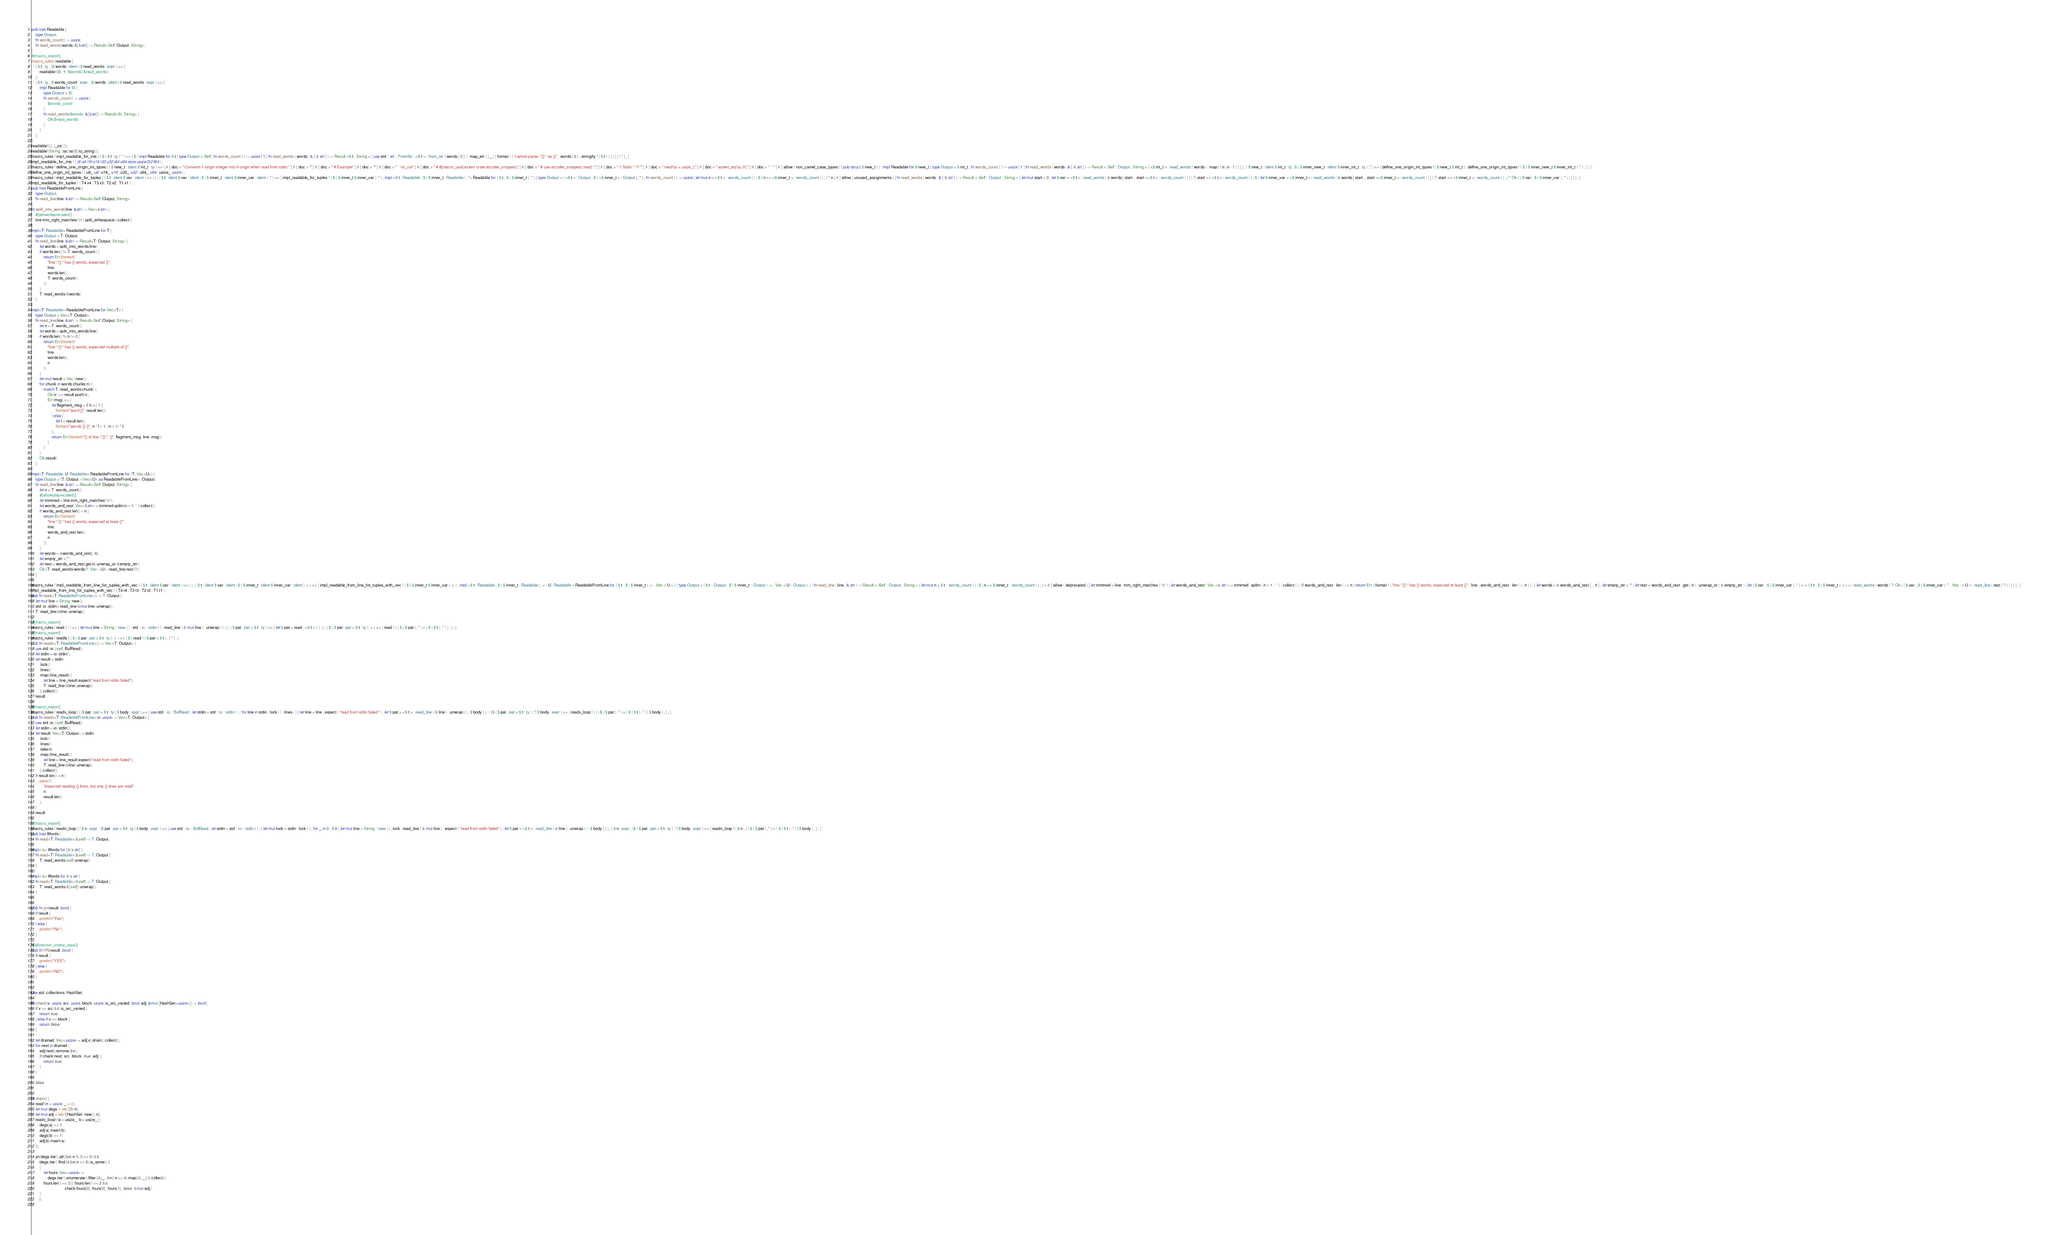<code> <loc_0><loc_0><loc_500><loc_500><_Rust_>pub trait Readable {
    type Output;
    fn words_count() -> usize;
    fn read_words(words: &[&str]) -> Result<Self::Output, String>;
}
#[macro_export]
macro_rules! readable {
    ( $ t : ty , |$ words : ident | $ read_words : expr ) => {
        readable!($t, 1, |$words| $read_words);
    };
    ( $ t : ty , $ words_count : expr , |$ words : ident | $ read_words : expr ) => {
        impl Readable for $t {
            type Output = $t;
            fn words_count() -> usize {
                $words_count
            }
            fn read_words($words: &[&str]) -> Result<$t, String> {
                Ok($read_words)
            }
        }
    };
}
readable!((), |_ss| ());
readable!(String, |ss| ss[0].to_string());
macro_rules ! impl_readable_for_ints { ( $ ( $ t : ty ) * ) => { $ ( impl Readable for $ t { type Output = Self ; fn words_count ( ) -> usize { 1 } fn read_words ( words : & [ & str ] ) -> Result <$ t , String > { use std :: str :: FromStr ; <$ t >:: from_str ( words [ 0 ] ) . map_err ( | _ | { format ! ( "cannot parse \"{}\" as {}" , words [ 0 ] , stringify ! ( $ t ) ) } ) } } ) * } ; }
impl_readable_for_ints ! ( i8 u8 i16 u16 i32 u32 i64 u64 isize usize f32 f64 ) ;
macro_rules ! define_one_origin_int_types { ( $ new_t : ident $ int_t : ty ) => { # [ doc = " Converts 1-origin integer into 0-origin when read from stdin." ] # [ doc = "" ] # [ doc = " # Example" ] # [ doc = "" ] # [ doc = " ```no_run" ] # [ doc = " # #[macro_use] extern crate atcoder_snippets;" ] # [ doc = " # use atcoder_snippets::read::*;" ] # [ doc = " // Stdin: \"1\"" ] # [ doc = " read!(a = usize_);" ] # [ doc = " assert_eq!(a, 0);" ] # [ doc = " ```" ] # [ allow ( non_camel_case_types ) ] pub struct $ new_t ( ) ; impl Readable for $ new_t { type Output = $ int_t ; fn words_count ( ) -> usize { 1 } fn read_words ( words : & [ & str ] ) -> Result < Self :: Output , String > { <$ int_t >:: read_words ( words ) . map ( | n | n - 1 ) } } } ; ( $ new_t : ident $ int_t : ty ; $ ( $ inner_new_t : ident $ inner_int_t : ty ) ;* ) => { define_one_origin_int_types ! ( $ new_t $ int_t ) ; define_one_origin_int_types ! ( $ ( $ inner_new_t $ inner_int_t ) ;* ) ; } ; }
define_one_origin_int_types ! ( u8_ u8 ; u16_ u16 ; u32_ u32 ; u64_ u64 ; usize_ usize ) ;
macro_rules ! impl_readable_for_tuples { ( $ t : ident $ var : ident ) => ( ) ; ( $ t : ident $ var : ident ; $ ( $ inner_t : ident $ inner_var : ident ) ;* ) => { impl_readable_for_tuples ! ( $ ( $ inner_t $ inner_var ) ;* ) ; impl <$ t : Readable , $ ( $ inner_t : Readable ) ,*> Readable for ( $ t , $ ( $ inner_t ) ,* ) { type Output = ( <$ t >:: Output , $ ( <$ inner_t >:: Output ) ,* ) ; fn words_count ( ) -> usize { let mut n = <$ t >:: words_count ( ) ; $ ( n += <$ inner_t >:: words_count ( ) ; ) * n } # [ allow ( unused_assignments ) ] fn read_words ( words : & [ & str ] ) -> Result < Self :: Output , String > { let mut start = 0 ; let $ var = <$ t >:: read_words ( & words [ start .. start +<$ t >:: words_count ( ) ] ) ?; start += <$ t >:: words_count ( ) ; $ ( let $ inner_var = <$ inner_t >:: read_words ( & words [ start .. start +<$ inner_t >:: words_count ( ) ] ) ?; start += <$ inner_t >:: words_count ( ) ; ) * Ok ( ( $ var , $ ( $ inner_var ) ,* ) ) } } } ; }
impl_readable_for_tuples ! ( T4 x4 ; T3 x3 ; T2 x2 ; T1 x1 ) ;
pub trait ReadableFromLine {
    type Output;
    fn read_line(line: &str) -> Result<Self::Output, String>;
}
fn split_into_words(line: &str) -> Vec<&str> {
    #[allow(deprecated)]
    line.trim_right_matches('\n').split_whitespace().collect()
}
impl<T: Readable> ReadableFromLine for T {
    type Output = T::Output;
    fn read_line(line: &str) -> Result<T::Output, String> {
        let words = split_into_words(line);
        if words.len() != T::words_count() {
            return Err(format!(
                "line \"{}\" has {} words, expected {}",
                line,
                words.len(),
                T::words_count()
            ));
        }
        T::read_words(&words)
    }
}
impl<T: Readable> ReadableFromLine for Vec<T> {
    type Output = Vec<T::Output>;
    fn read_line(line: &str) -> Result<Self::Output, String> {
        let n = T::words_count();
        let words = split_into_words(line);
        if words.len() % n != 0 {
            return Err(format!(
                "line \"{}\" has {} words, expected multiple of {}",
                line,
                words.len(),
                n
            ));
        }
        let mut result = Vec::new();
        for chunk in words.chunks(n) {
            match T::read_words(chunk) {
                Ok(v) => result.push(v),
                Err(msg) => {
                    let flagment_msg = if n == 1 {
                        format!("word {}", result.len())
                    } else {
                        let l = result.len();
                        format!("words {}-{}", n * l + 1, (n + 1) * l)
                    };
                    return Err(format!("{} of line \"{}\": {}", flagment_msg, line, msg));
                }
            }
        }
        Ok(result)
    }
}
impl<T: Readable, U: Readable> ReadableFromLine for (T, Vec<U>) {
    type Output = (T::Output, <Vec<U> as ReadableFromLine>::Output);
    fn read_line(line: &str) -> Result<Self::Output, String> {
        let n = T::words_count();
        #[allow(deprecated)]
        let trimmed = line.trim_right_matches('\n');
        let words_and_rest: Vec<&str> = trimmed.splitn(n + 1, ' ').collect();
        if words_and_rest.len() < n {
            return Err(format!(
                "line \"{}\" has {} words, expected at least {}",
                line,
                words_and_rest.len(),
                n
            ));
        }
        let words = &words_and_rest[..n];
        let empty_str = "";
        let rest = words_and_rest.get(n).unwrap_or(&empty_str);
        Ok((T::read_words(words)?, Vec::<U>::read_line(rest)?))
    }
}
macro_rules ! impl_readable_from_line_for_tuples_with_vec { ( $ t : ident $ var : ident ) => ( ) ; ( $ t : ident $ var : ident ; $ ( $ inner_t : ident $ inner_var : ident ) ;+ ) => { impl_readable_from_line_for_tuples_with_vec ! ( $ ( $ inner_t $ inner_var ) ;+ ) ; impl <$ t : Readable , $ ( $ inner_t : Readable ) ,+ , U : Readable > ReadableFromLine for ( $ t , $ ( $ inner_t ) ,+ , Vec < U > ) { type Output = ( $ t :: Output , $ ( $ inner_t :: Output ) ,+ , Vec < U :: Output > ) ; fn read_line ( line : & str ) -> Result < Self :: Output , String > { let mut n = $ t :: words_count ( ) ; $ ( n += $ inner_t :: words_count ( ) ; ) + # [ allow ( deprecated ) ] let trimmed = line . trim_right_matches ( '\n' ) ; let words_and_rest : Vec <& str > = trimmed . splitn ( n + 1 , ' ' ) . collect ( ) ; if words_and_rest . len ( ) < n { return Err ( format ! ( "line \"{}\" has {} words, expected at least {}" , line , words_and_rest . len ( ) , n ) ) ; } let words = & words_and_rest [ .. n ] ; let empty_str = "" ; let rest = words_and_rest . get ( n ) . unwrap_or ( & empty_str ) ; let ( $ var , $ ( $ inner_var ) ,* ) = < ( $ t , $ ( $ inner_t ) ,+ ) >:: read_words ( words ) ?; Ok ( ( $ var , $ ( $ inner_var ) ,* , Vec ::< U >:: read_line ( rest ) ? ) ) } } } ; }
impl_readable_from_line_for_tuples_with_vec ! ( T4 t4 ; T3 t3 ; T2 t2 ; T1 t1 ) ;
pub fn read<T: ReadableFromLine>() -> T::Output {
    let mut line = String::new();
    std::io::stdin().read_line(&mut line).unwrap();
    T::read_line(&line).unwrap()
}
#[macro_export]
macro_rules ! read { ( ) => { let mut line = String :: new ( ) ; std :: io :: stdin ( ) . read_line ( & mut line ) . unwrap ( ) ; } ; ( $ pat : pat = $ t : ty ) => { let $ pat = read ::<$ t > ( ) ; } ; ( $ ( $ pat : pat = $ t : ty ) ,+ ) => { read ! ( ( $ ( $ pat ) ,* ) = ( $ ( $ t ) ,* ) ) ; } ; }
#[macro_export]
macro_rules ! readls { ( $ ( $ pat : pat = $ t : ty ) ,+ ) => { $ ( read ! ( $ pat = $ t ) ; ) * } ; }
pub fn readx<T: ReadableFromLine>() -> Vec<T::Output> {
    use std::io::{self, BufRead};
    let stdin = io::stdin();
    let result = stdin
        .lock()
        .lines()
        .map(|line_result| {
            let line = line_result.expect("read from stdin failed");
            T::read_line(&line).unwrap()
        }).collect();
    result
}
#[macro_export]
macro_rules ! readx_loop { ( |$ pat : pat = $ t : ty | $ body : expr ) => { use std :: io :: BufRead ; let stdin = std :: io :: stdin ( ) ; for line in stdin . lock ( ) . lines ( ) { let line = line . expect ( "read from stdin failed" ) ; let $ pat = <$ t >:: read_line ( & line ) . unwrap ( ) ; $ body } } ; ( |$ ( $ pat : pat = $ t : ty ) ,*| $ body : expr ) => { readx_loop ! ( | ( $ ( $ pat ) ,* ) = ( $ ( $ t ) ,* ) | $ body ) ; } ; }
pub fn readn<T: ReadableFromLine>(n: usize) -> Vec<T::Output> {
    use std::io::{self, BufRead};
    let stdin = io::stdin();
    let result: Vec<T::Output> = stdin
        .lock()
        .lines()
        .take(n)
        .map(|line_result| {
            let line = line_result.expect("read from stdin failed");
            T::read_line(&line).unwrap()
        }).collect();
    if result.len() < n {
        panic!(
            "expected reading {} lines, but only {} lines are read",
            n,
            result.len()
        );
    }
    result
}
#[macro_export]
macro_rules ! readn_loop { ( $ n : expr , |$ pat : pat = $ t : ty | $ body : expr ) => { use std :: io :: BufRead ; let stdin = std :: io :: stdin ( ) ; { let mut lock = stdin . lock ( ) ; for _ in 0 ..$ n { let mut line = String :: new ( ) ; lock . read_line ( & mut line ) . expect ( "read from stdin failed" ) ; let $ pat = <$ t >:: read_line ( & line ) . unwrap ( ) ; $ body } } } ; ( $ n : expr , |$ ( $ pat : pat = $ t : ty ) ,*| $ body : expr ) => { readn_loop ! ( $ n , | ( $ ( $ pat ) ,* ) = ( $ ( $ t ) ,* ) | $ body ) ; } ; }
pub trait Words {
    fn read<T: Readable>(&self) -> T::Output;
}
impl<'a> Words for [&'a str] {
    fn read<T: Readable>(&self) -> T::Output {
        T::read_words(self).unwrap()
    }
}
impl<'a> Words for &'a str {
    fn read<T: Readable>(&self) -> T::Output {
        T::read_words(&[self]).unwrap()
    }
}

pub fn yn(result: bool) {
    if result {
        println!("Yes");
    } else {
        println!("No");
    }
}
#[allow(non_snake_case)]
pub fn YN(result: bool) {
    if result {
        println!("YES");
    } else {
        println!("NO");
    }
}

use std::collections::HashSet;

fn check(v: usize, src: usize, block: usize, is_src_visited: bool, adj: &mut [HashSet<usize>]) -> bool {
    if v == src && is_src_visited {
        return true;
    } else if v == block {
        return false;
    }

    let drained: Vec<usize> = adj[v].drain().collect();
    for next in drained {
        adj[next].remove(&v);
        if check(next, src, block, true, adj) {
            return true;
        }
    }

    false
}

fn main() {
    read!(n = usize, _ = ());
    let mut degs = vec![0; n];
    let mut adj = vec![HashSet::new(); n];
    readx_loop!(|a = usize_, b = usize_| {
        degs[a] += 1;
        adj[a].insert(b);
        degs[b] += 1;
        adj[b].insert(a);
    });

    yn(degs.iter().all(|&n| n % 2 == 0) &&
       (degs.iter().find(|&&n| n >= 6).is_some() ||
        {
            let fours: Vec<usize> =
                degs.iter().enumerate().filter(|&(_, &n)| n == 4).map(|(i, _)| i).collect();
            fours.len() >= 3 || (fours.len() == 2 &&
                                 check(fours[0], fours[0], fours[1], false, &mut adj))
        }
       ));
}
</code> 